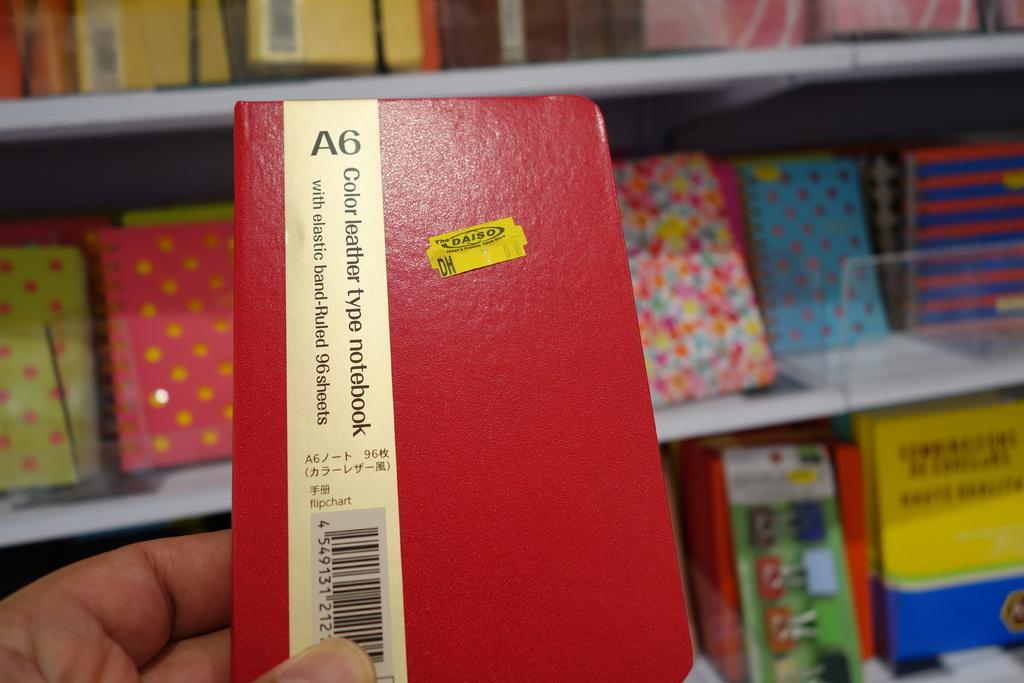<image>
Describe the image concisely. A red notebook with the A6 written along the  top and a yellow speaker. 